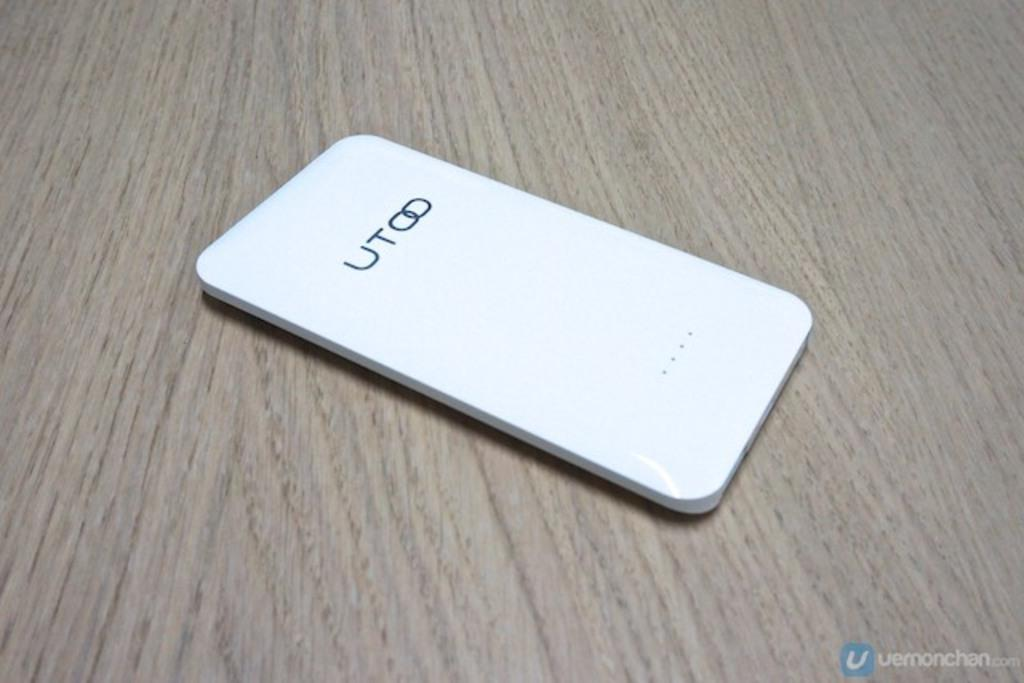<image>
Give a short and clear explanation of the subsequent image. A face down mobile phone with UTOO on the back. 